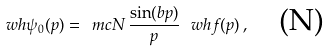Convert formula to latex. <formula><loc_0><loc_0><loc_500><loc_500>\ w h { \psi } _ { 0 } ( p ) = \ m c { N } \, \frac { \sin ( b p ) } { p } \, \ w h { f } ( p ) \, , \quad \text {(N)}</formula> 